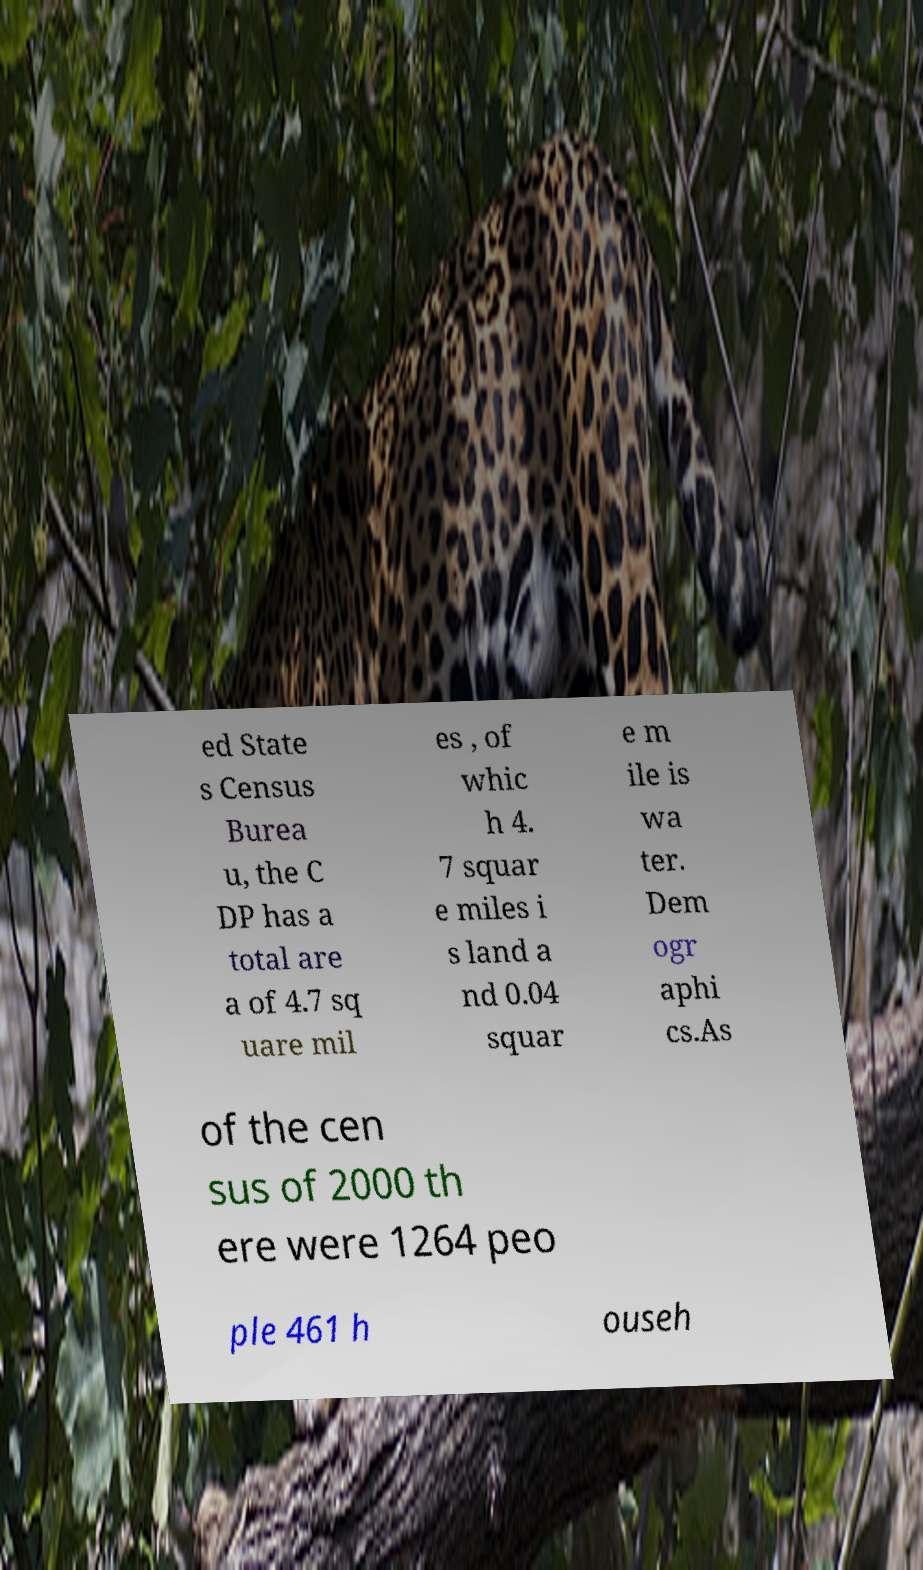I need the written content from this picture converted into text. Can you do that? ed State s Census Burea u, the C DP has a total are a of 4.7 sq uare mil es , of whic h 4. 7 squar e miles i s land a nd 0.04 squar e m ile is wa ter. Dem ogr aphi cs.As of the cen sus of 2000 th ere were 1264 peo ple 461 h ouseh 